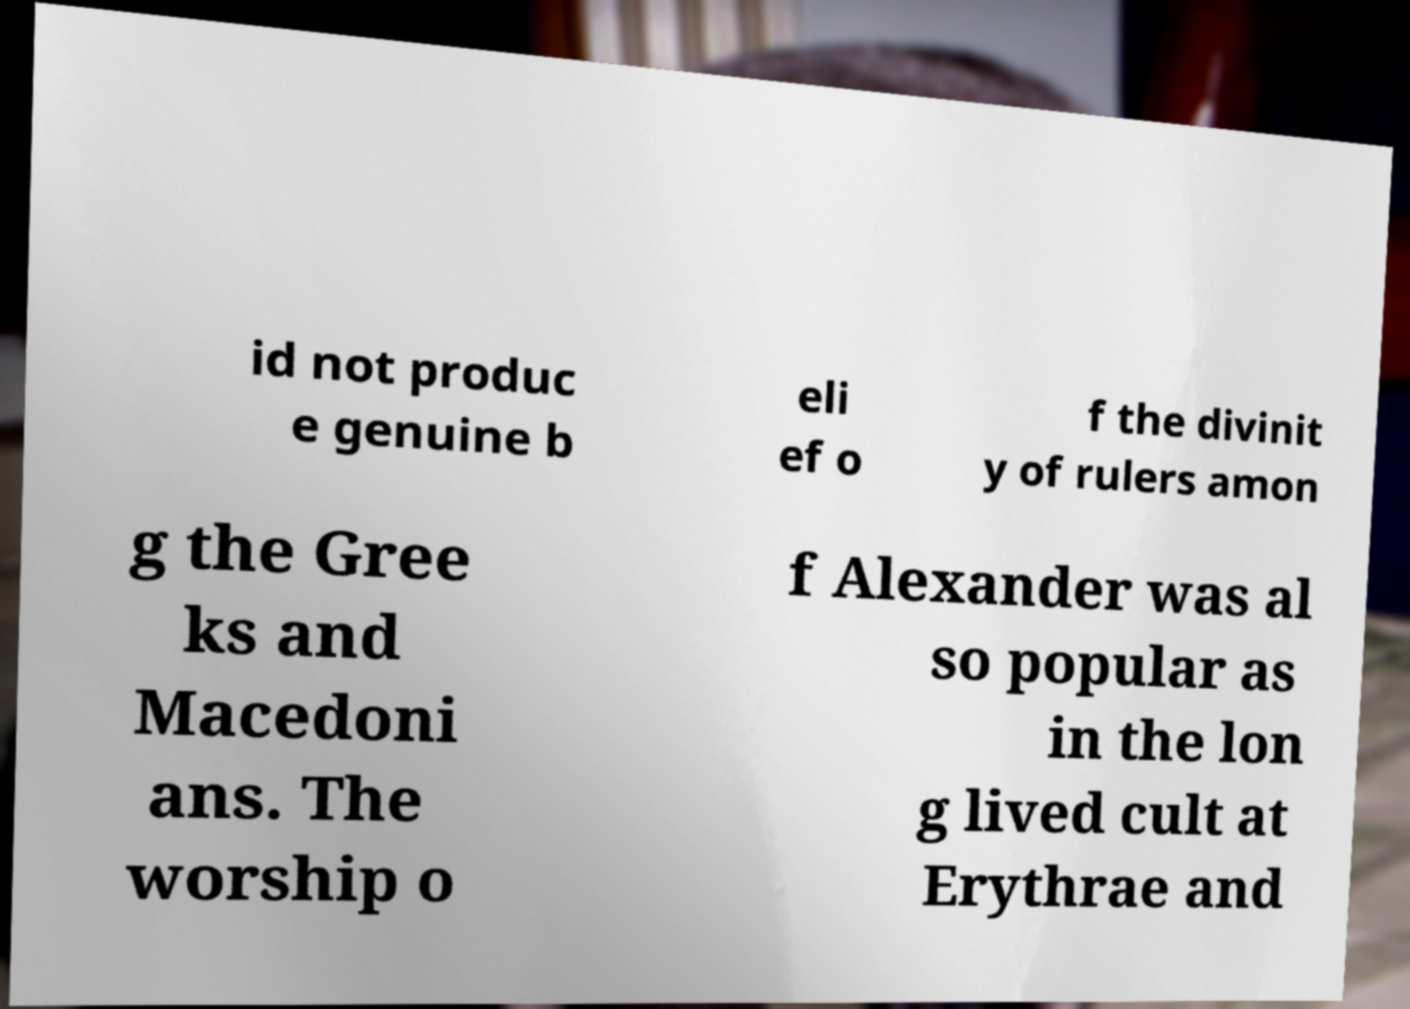Can you read and provide the text displayed in the image?This photo seems to have some interesting text. Can you extract and type it out for me? id not produc e genuine b eli ef o f the divinit y of rulers amon g the Gree ks and Macedoni ans. The worship o f Alexander was al so popular as in the lon g lived cult at Erythrae and 